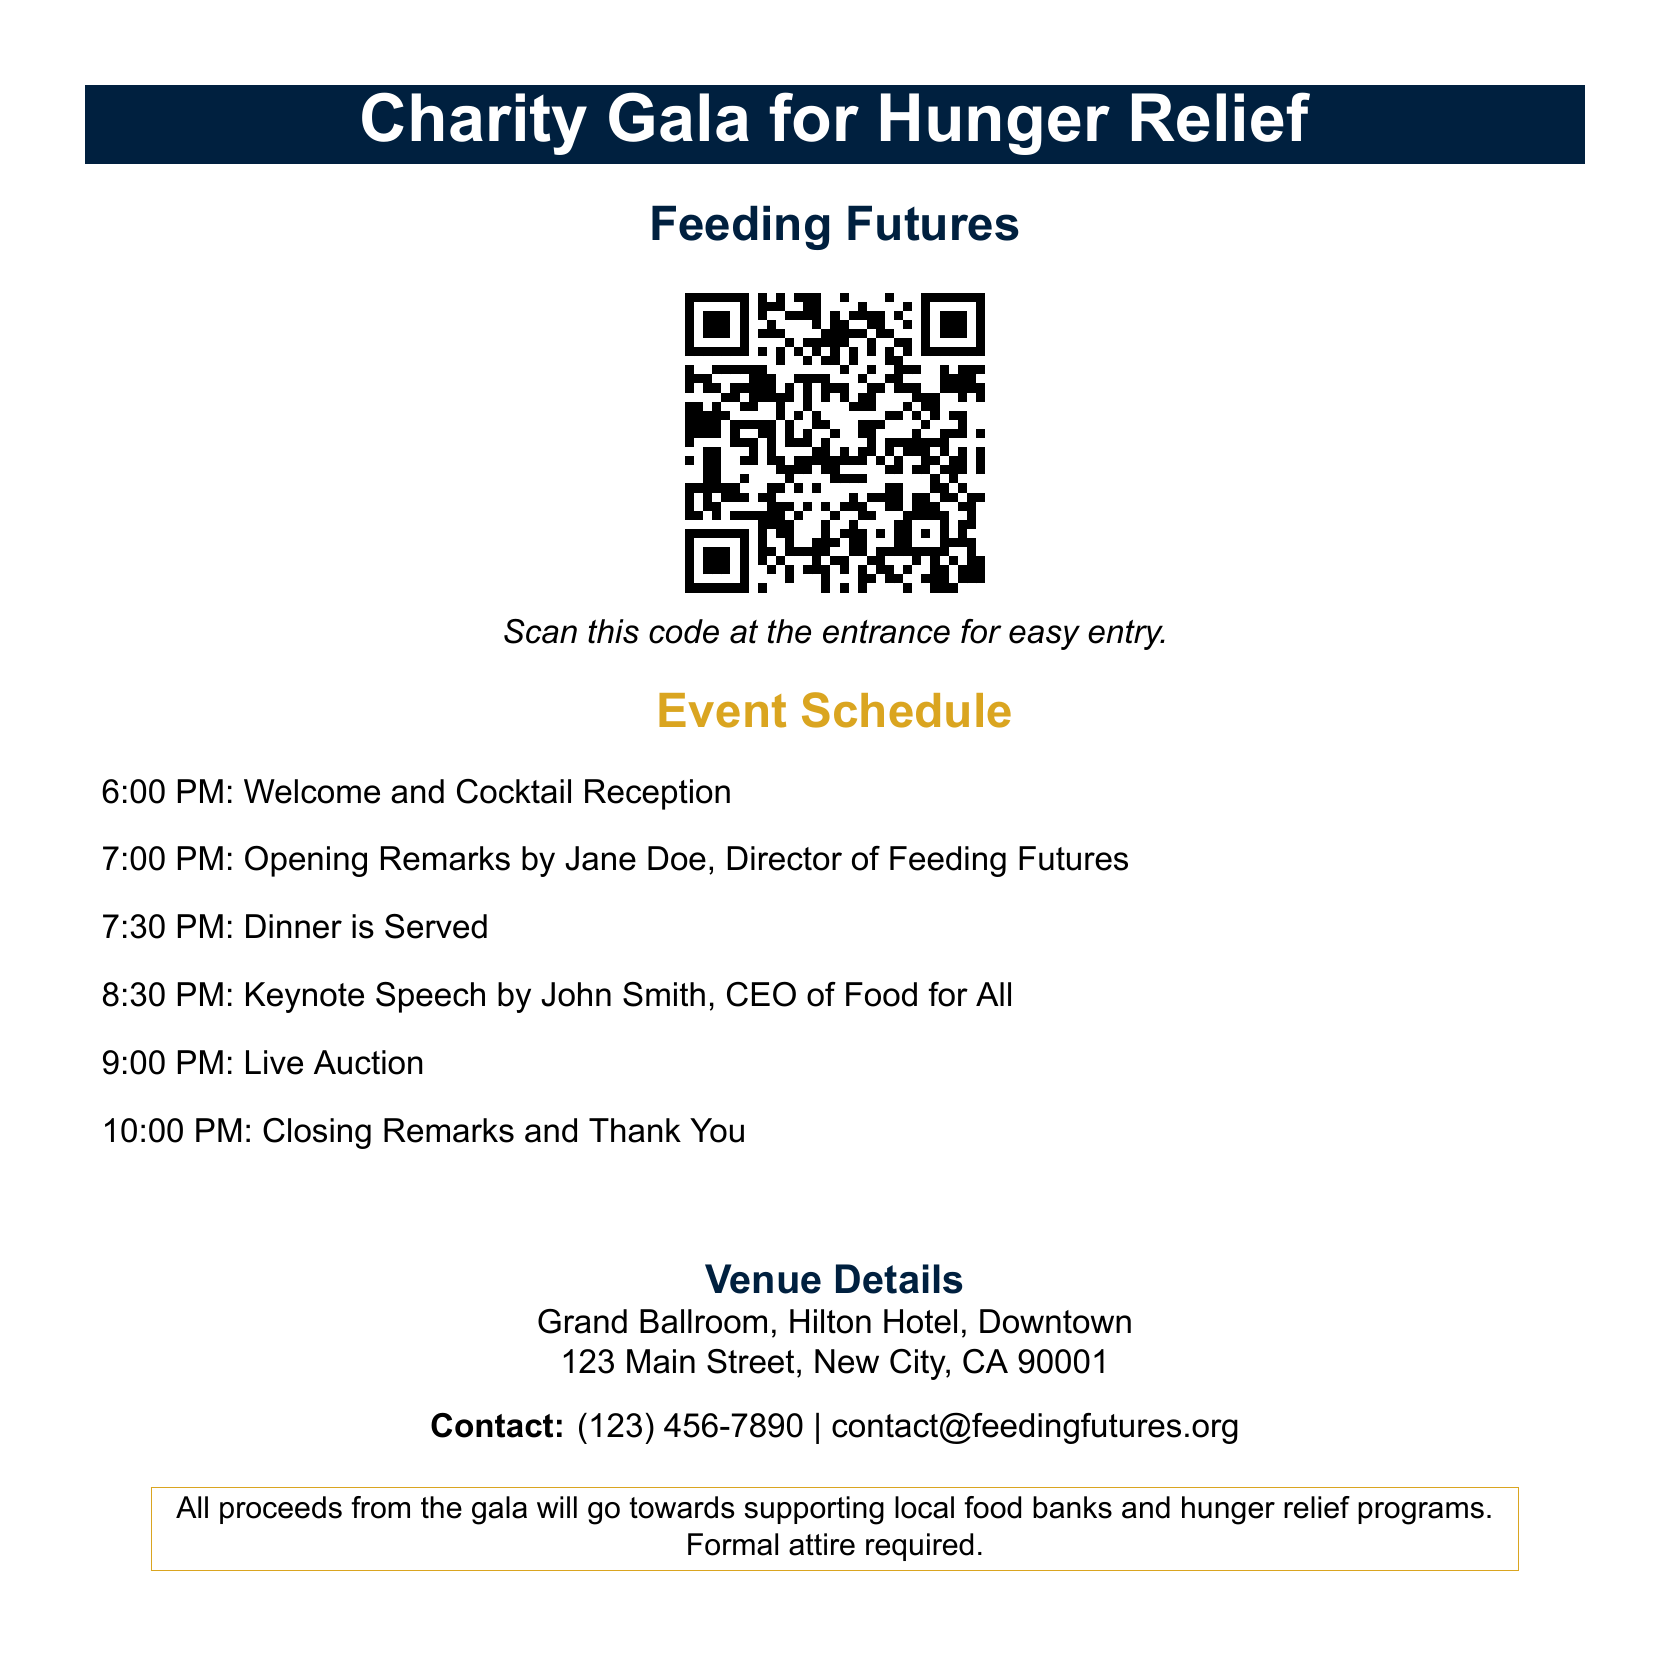What is the event title? The event title is prominently displayed at the top of the document, labeled as "Charity Gala for Hunger Relief."
Answer: Charity Gala for Hunger Relief What is the name of the director giving opening remarks? The document specifies that Jane Doe is the director giving the opening remarks.
Answer: Jane Doe What time does dinner start? The schedule indicates that dinner is served at 7:30 PM.
Answer: 7:30 PM What is the venue for the event? The venue details section provides the location as Grand Ballroom, Hilton Hotel, Downtown.
Answer: Grand Ballroom, Hilton Hotel, Downtown What is the contact phone number provided? The contact information section includes a phone number which is (123) 456-7890.
Answer: (123) 456-7890 What type of attire is required? The document specifies that formal attire is required for the gala.
Answer: Formal attire How can attendees enter the event? The QR code allows for easy entry by scanning it at the entrance.
Answer: Scan the QR code What time does the live auction start? The event schedule lists the live auction starting at 9:00 PM.
Answer: 9:00 PM What is the primary purpose of the gala? The document states that all proceeds will support local food banks and hunger relief programs.
Answer: Supporting local food banks and hunger relief programs 